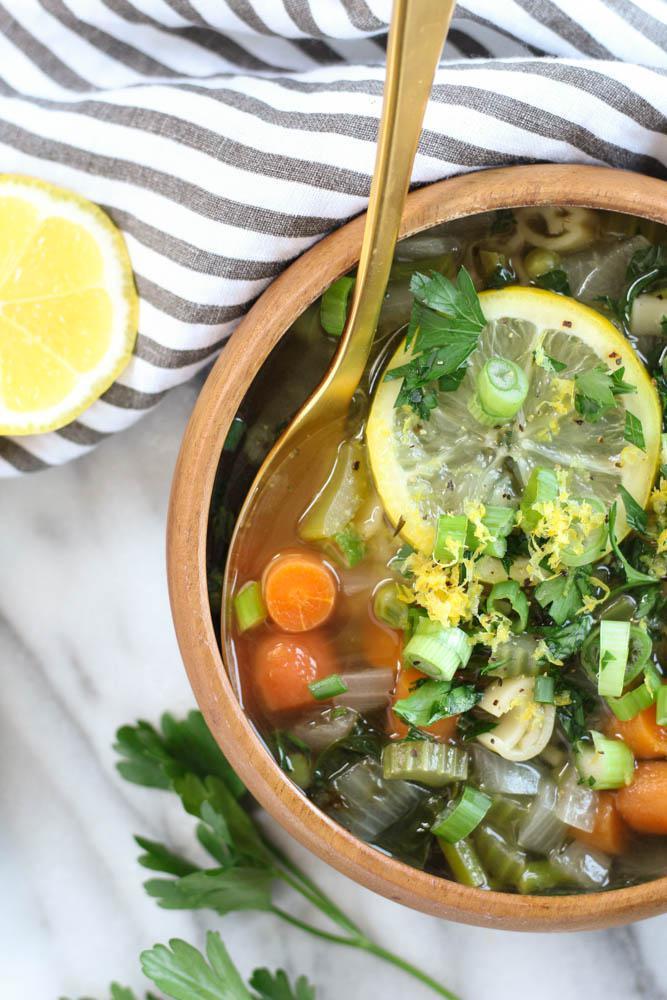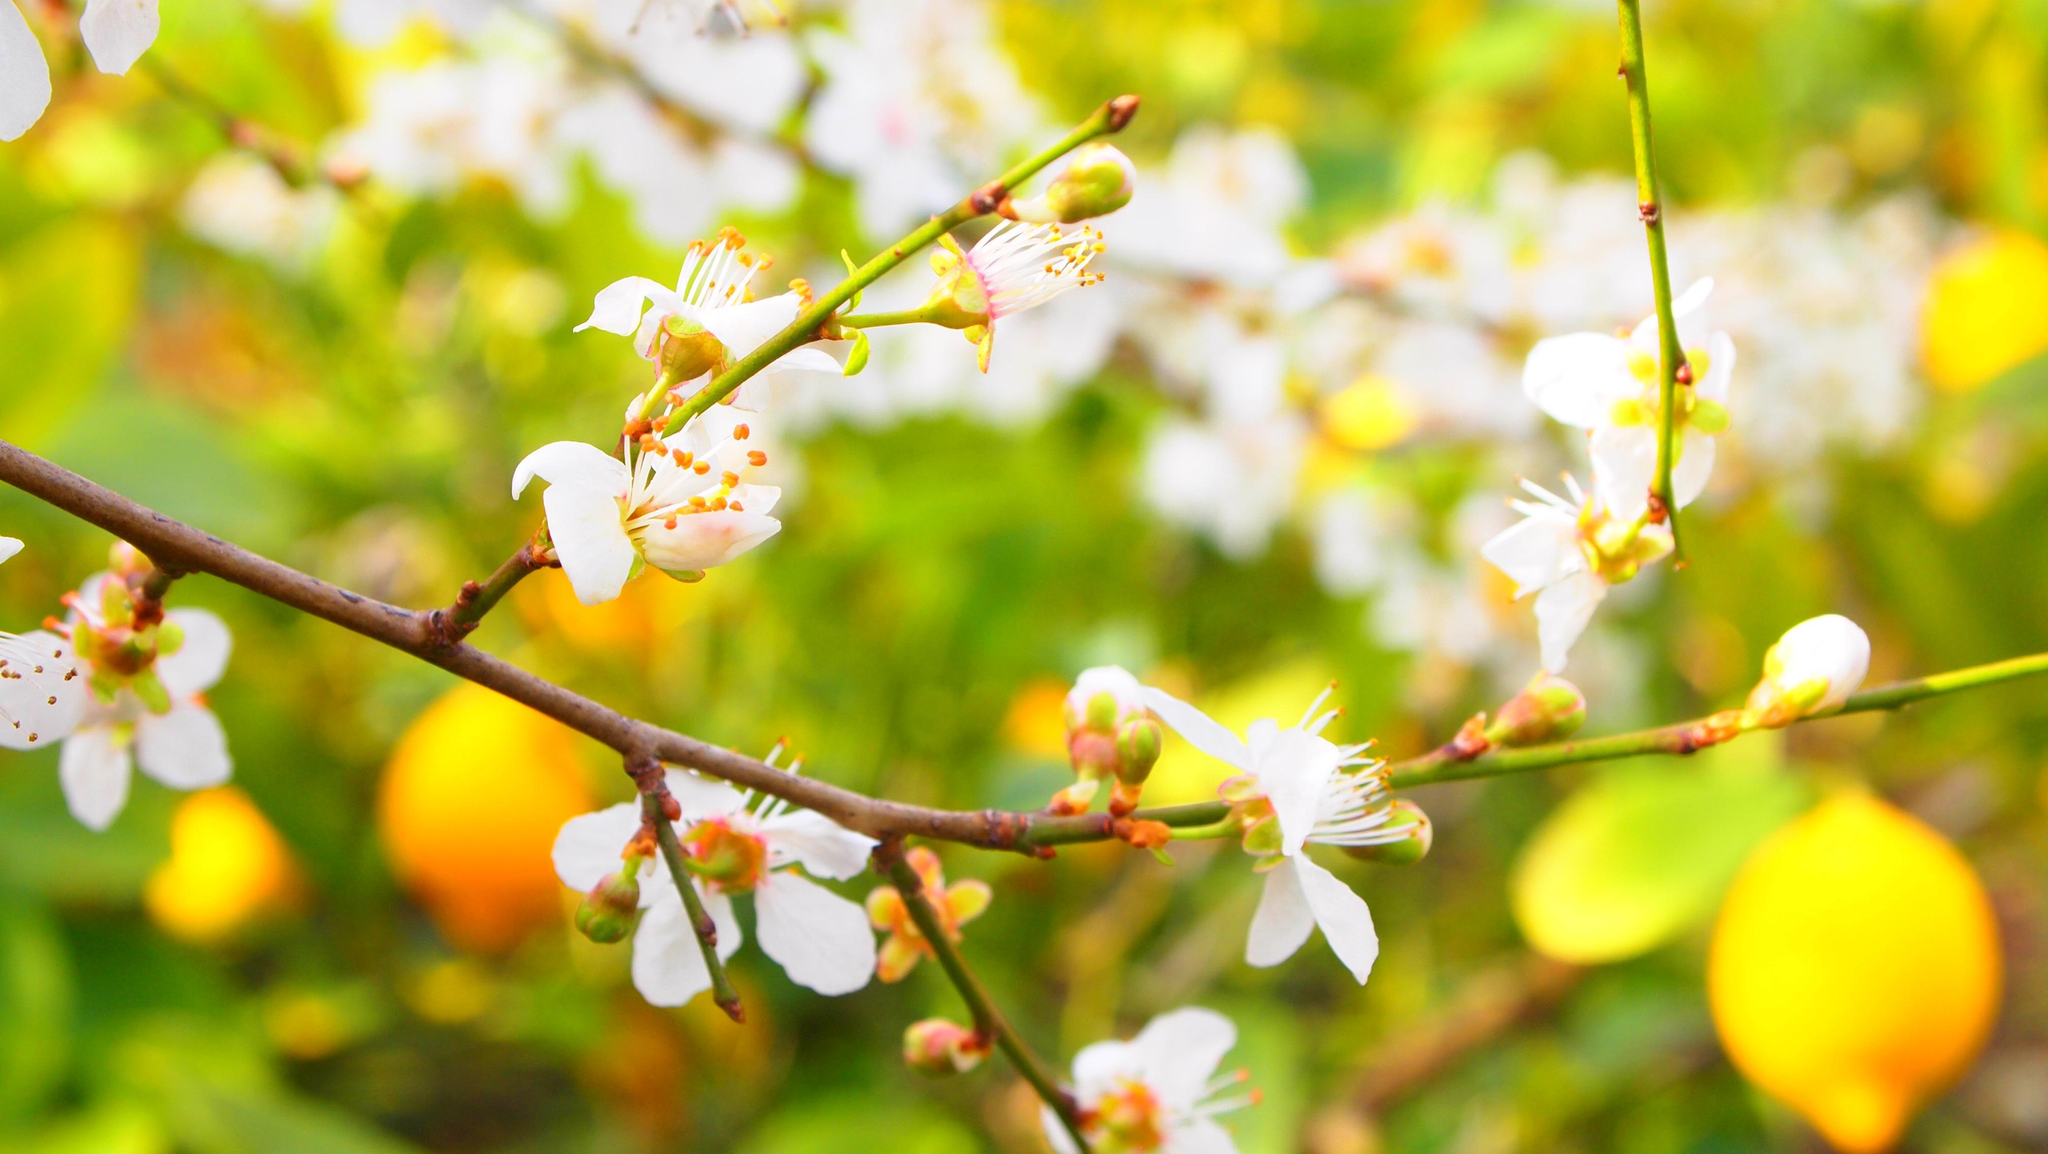The first image is the image on the left, the second image is the image on the right. Examine the images to the left and right. Is the description "One spoon is resting in a bowl of food containing lemons." accurate? Answer yes or no. Yes. The first image is the image on the left, the second image is the image on the right. Assess this claim about the two images: "One image features a scattered display on a painted wood surface that includes whole lemons, cut lemons, and green leaves.". Correct or not? Answer yes or no. No. 